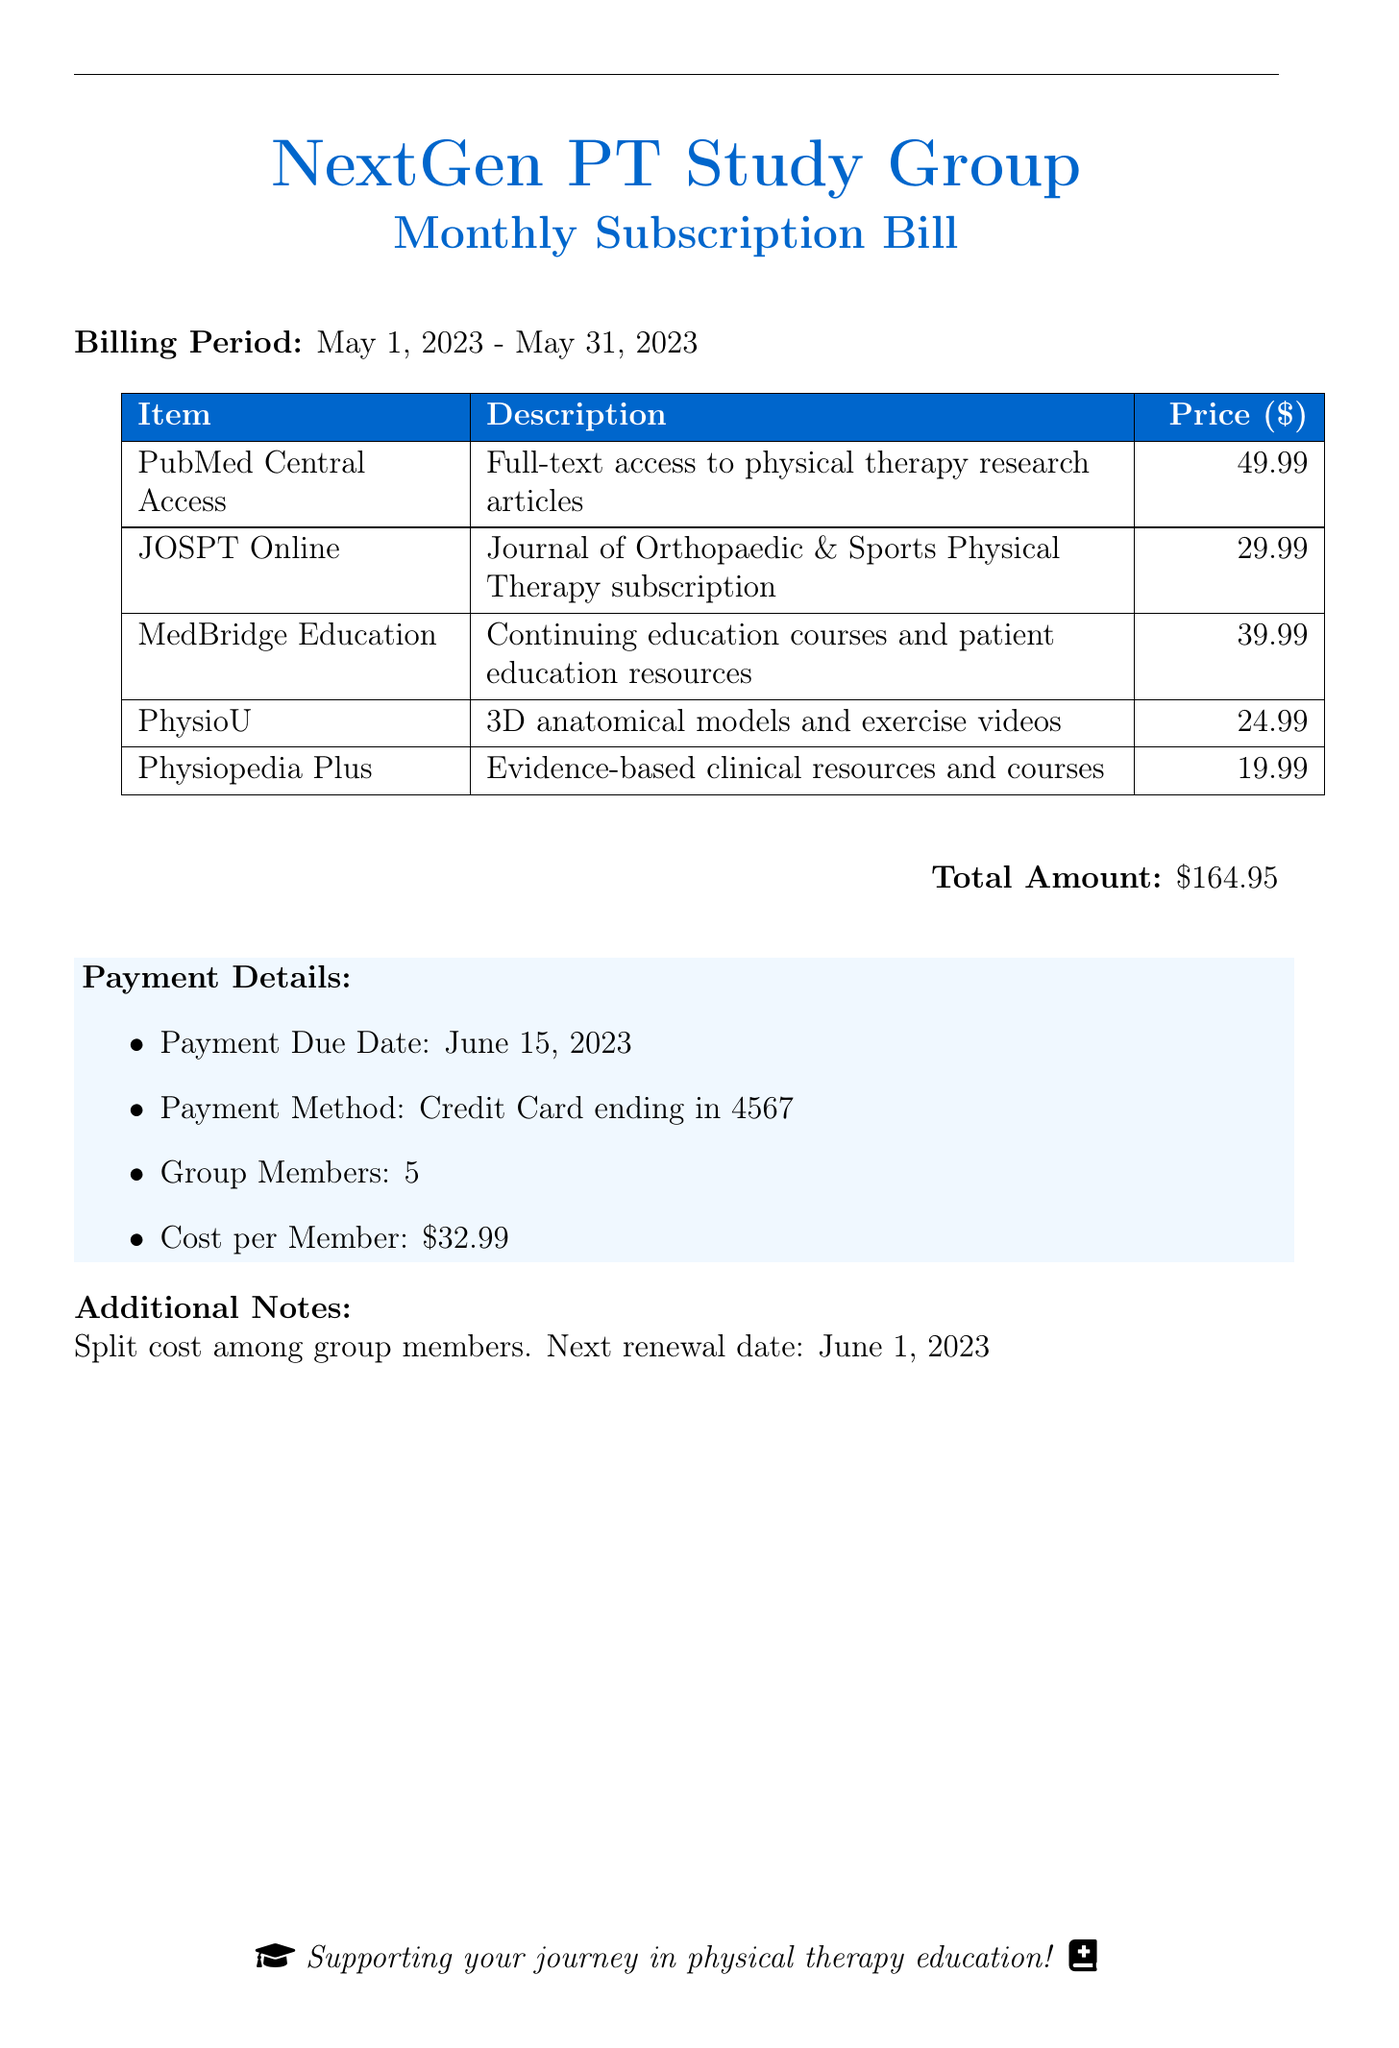What is the billing period? The billing period is stated clearly in the document as the duration for the current charges, which is from May 1, 2023 to May 31, 2023.
Answer: May 1, 2023 - May 31, 2023 What is the cost of the MedBridge Education subscription? The document lists the cost associated with each subscription item, specifically indicating that MedBridge Education costs $39.99.
Answer: 39.99 How many group members are there? The number of group members is explicitly mentioned in the payment details section of the bill.
Answer: 5 What is the total amount due? The total amount mentioned at the bottom of the bill sums up all subscription costs listed, which is $164.95.
Answer: $164.95 When is the payment due date? The due date for the payment is specified in the payment details section of the document.
Answer: June 15, 2023 What is the average cost per member? The cost per member is calculated by dividing the total amount by the number of group members, which is clearly stated as $32.99.
Answer: $32.99 What will the next renewal date be? The document states the next renewal date, which is relevant for future budgeting and planning.
Answer: June 1, 2023 What type of resources does the PhysioU subscription provide? The description for the PhysioU subscription indicates that it provides specific educational tools, which are 3D anatomical models and exercise videos.
Answer: 3D anatomical models and exercise videos Which payment method is used? The payment details explicitly mention the method of payment, which is a credit card ending in the last four digits.
Answer: Credit Card ending in 4567 